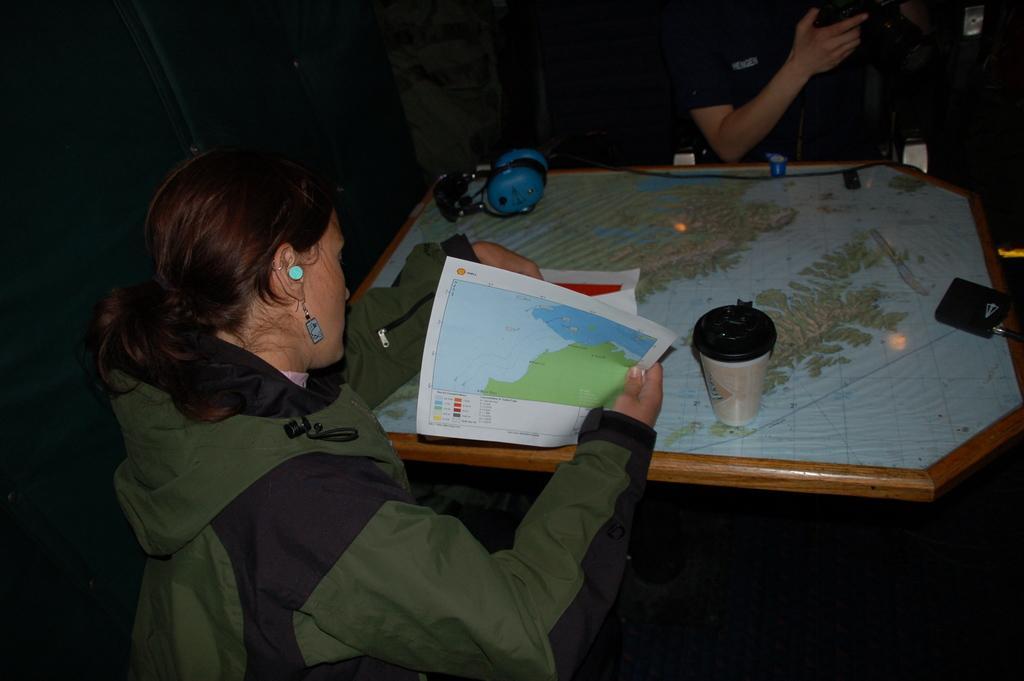Could you give a brief overview of what you see in this image? In this picture we can see woman sitting and holding papers in her hands and in front of her on table we can see glass, map and in background we can see other person and it is dark. 